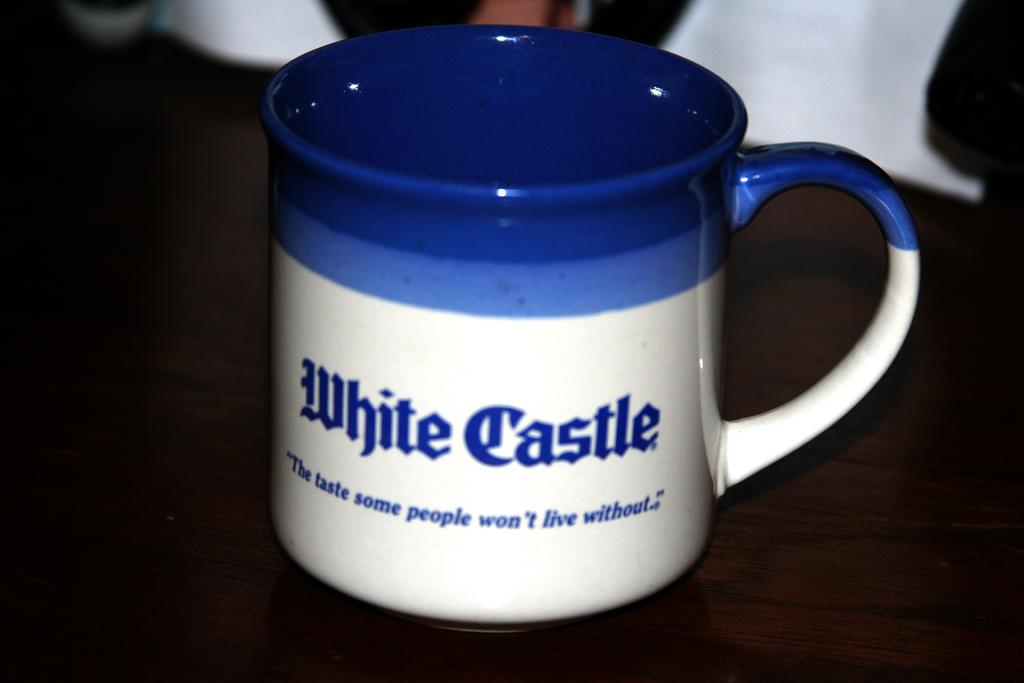What is the name on the mug?
Provide a succinct answer. White castle. What can't some people live without?
Keep it short and to the point. The taste. 